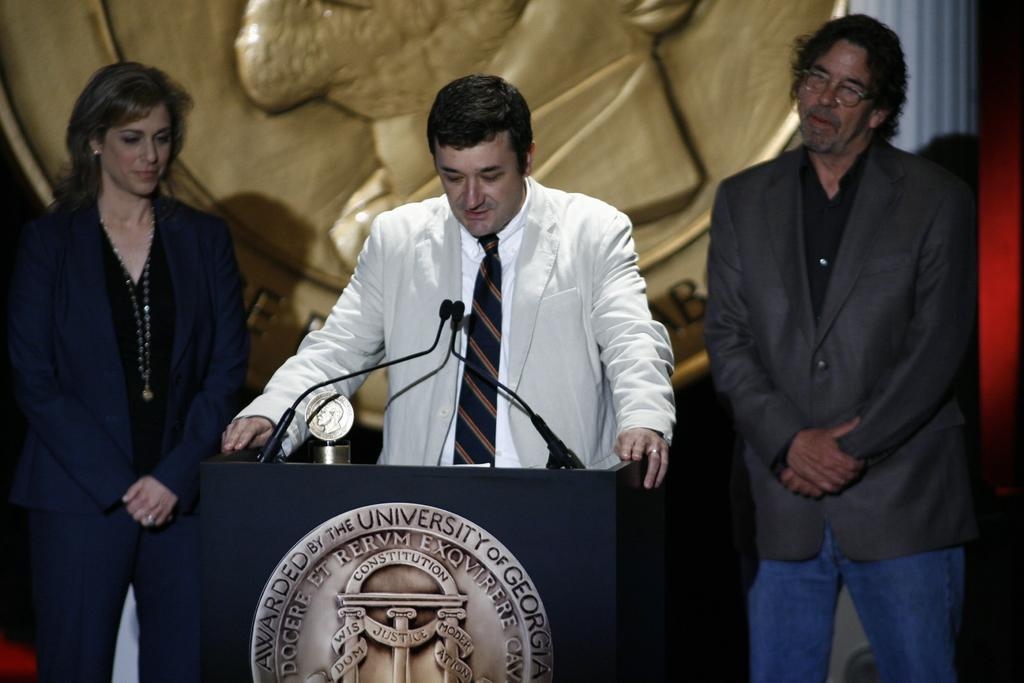What is the man in the image doing? The man is talking on a microphone. What object is present in the image that is often used for speeches or presentations? There is a podium in the image. What item in the image might be awarded to someone for their achievements? There is a trophy in the image. How many people are present in the image? There are two persons in the image. What architectural feature can be seen in the image? There is a pillar in the image. Where is the farm located in the image? There is no farm present in the image. What type of swing can be seen in the image? There is no swing present in the image. 